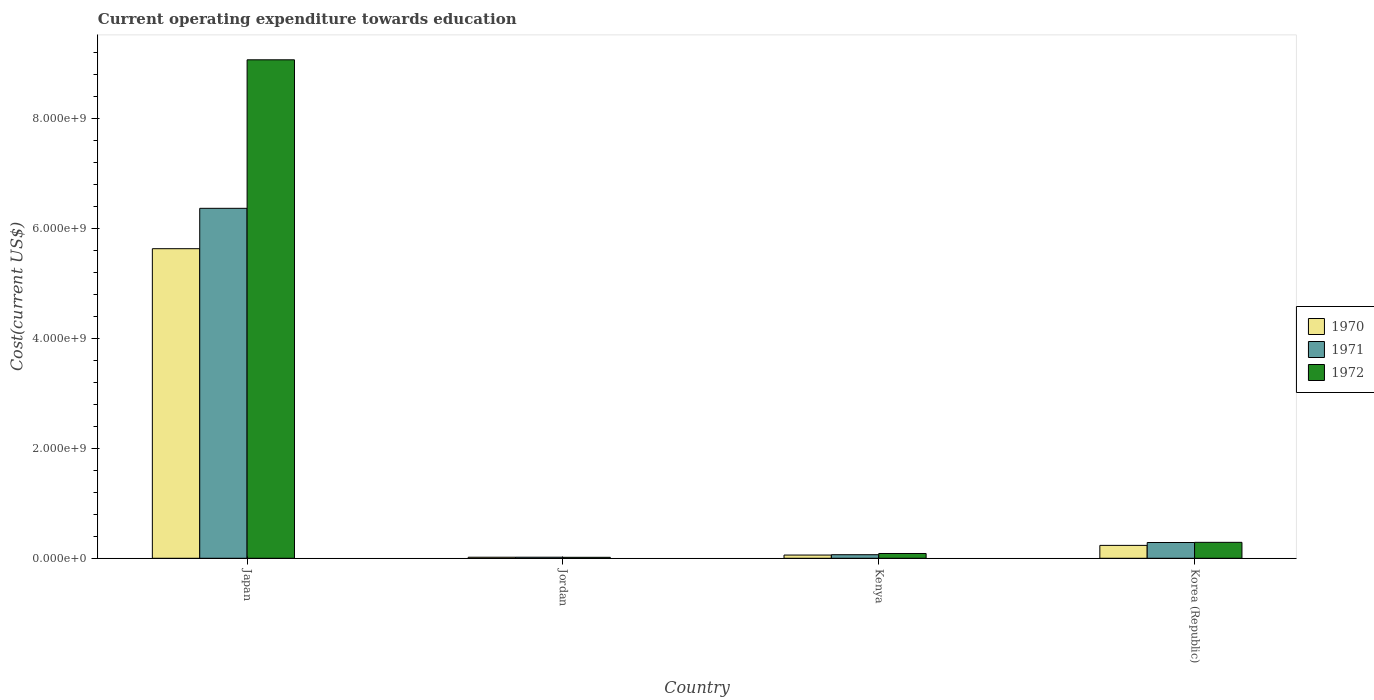How many groups of bars are there?
Your answer should be very brief. 4. Are the number of bars per tick equal to the number of legend labels?
Offer a terse response. Yes. Are the number of bars on each tick of the X-axis equal?
Your response must be concise. Yes. What is the label of the 3rd group of bars from the left?
Provide a succinct answer. Kenya. In how many cases, is the number of bars for a given country not equal to the number of legend labels?
Offer a very short reply. 0. What is the expenditure towards education in 1970 in Kenya?
Offer a terse response. 5.85e+07. Across all countries, what is the maximum expenditure towards education in 1971?
Your answer should be very brief. 6.37e+09. Across all countries, what is the minimum expenditure towards education in 1972?
Provide a succinct answer. 1.76e+07. In which country was the expenditure towards education in 1972 maximum?
Keep it short and to the point. Japan. In which country was the expenditure towards education in 1971 minimum?
Ensure brevity in your answer.  Jordan. What is the total expenditure towards education in 1972 in the graph?
Make the answer very short. 9.47e+09. What is the difference between the expenditure towards education in 1971 in Kenya and that in Korea (Republic)?
Provide a short and direct response. -2.22e+08. What is the difference between the expenditure towards education in 1972 in Kenya and the expenditure towards education in 1970 in Korea (Republic)?
Offer a terse response. -1.47e+08. What is the average expenditure towards education in 1972 per country?
Provide a short and direct response. 2.37e+09. What is the difference between the expenditure towards education of/in 1972 and expenditure towards education of/in 1970 in Jordan?
Provide a short and direct response. -1.49e+06. What is the ratio of the expenditure towards education in 1971 in Jordan to that in Kenya?
Give a very brief answer. 0.3. Is the expenditure towards education in 1971 in Kenya less than that in Korea (Republic)?
Provide a short and direct response. Yes. What is the difference between the highest and the second highest expenditure towards education in 1970?
Your answer should be very brief. 5.40e+09. What is the difference between the highest and the lowest expenditure towards education in 1972?
Make the answer very short. 9.05e+09. In how many countries, is the expenditure towards education in 1971 greater than the average expenditure towards education in 1971 taken over all countries?
Provide a short and direct response. 1. Is the sum of the expenditure towards education in 1971 in Jordan and Kenya greater than the maximum expenditure towards education in 1972 across all countries?
Ensure brevity in your answer.  No. What does the 1st bar from the left in Kenya represents?
Ensure brevity in your answer.  1970. Is it the case that in every country, the sum of the expenditure towards education in 1971 and expenditure towards education in 1970 is greater than the expenditure towards education in 1972?
Give a very brief answer. Yes. How many bars are there?
Offer a very short reply. 12. What is the difference between two consecutive major ticks on the Y-axis?
Provide a succinct answer. 2.00e+09. Does the graph contain any zero values?
Keep it short and to the point. No. How many legend labels are there?
Your answer should be compact. 3. What is the title of the graph?
Your answer should be very brief. Current operating expenditure towards education. Does "2006" appear as one of the legend labels in the graph?
Your response must be concise. No. What is the label or title of the Y-axis?
Offer a very short reply. Cost(current US$). What is the Cost(current US$) in 1970 in Japan?
Ensure brevity in your answer.  5.63e+09. What is the Cost(current US$) in 1971 in Japan?
Offer a terse response. 6.37e+09. What is the Cost(current US$) in 1972 in Japan?
Make the answer very short. 9.07e+09. What is the Cost(current US$) in 1970 in Jordan?
Ensure brevity in your answer.  1.91e+07. What is the Cost(current US$) of 1971 in Jordan?
Give a very brief answer. 1.94e+07. What is the Cost(current US$) of 1972 in Jordan?
Your answer should be compact. 1.76e+07. What is the Cost(current US$) of 1970 in Kenya?
Provide a succinct answer. 5.85e+07. What is the Cost(current US$) of 1971 in Kenya?
Your response must be concise. 6.49e+07. What is the Cost(current US$) in 1972 in Kenya?
Keep it short and to the point. 8.71e+07. What is the Cost(current US$) of 1970 in Korea (Republic)?
Provide a short and direct response. 2.34e+08. What is the Cost(current US$) in 1971 in Korea (Republic)?
Your answer should be very brief. 2.87e+08. What is the Cost(current US$) in 1972 in Korea (Republic)?
Offer a terse response. 2.90e+08. Across all countries, what is the maximum Cost(current US$) of 1970?
Provide a short and direct response. 5.63e+09. Across all countries, what is the maximum Cost(current US$) of 1971?
Provide a short and direct response. 6.37e+09. Across all countries, what is the maximum Cost(current US$) of 1972?
Your response must be concise. 9.07e+09. Across all countries, what is the minimum Cost(current US$) in 1970?
Make the answer very short. 1.91e+07. Across all countries, what is the minimum Cost(current US$) of 1971?
Your response must be concise. 1.94e+07. Across all countries, what is the minimum Cost(current US$) in 1972?
Your answer should be compact. 1.76e+07. What is the total Cost(current US$) in 1970 in the graph?
Offer a terse response. 5.95e+09. What is the total Cost(current US$) in 1971 in the graph?
Your answer should be compact. 6.74e+09. What is the total Cost(current US$) of 1972 in the graph?
Offer a terse response. 9.47e+09. What is the difference between the Cost(current US$) of 1970 in Japan and that in Jordan?
Give a very brief answer. 5.62e+09. What is the difference between the Cost(current US$) in 1971 in Japan and that in Jordan?
Ensure brevity in your answer.  6.35e+09. What is the difference between the Cost(current US$) in 1972 in Japan and that in Jordan?
Give a very brief answer. 9.05e+09. What is the difference between the Cost(current US$) in 1970 in Japan and that in Kenya?
Give a very brief answer. 5.58e+09. What is the difference between the Cost(current US$) in 1971 in Japan and that in Kenya?
Keep it short and to the point. 6.30e+09. What is the difference between the Cost(current US$) in 1972 in Japan and that in Kenya?
Offer a very short reply. 8.99e+09. What is the difference between the Cost(current US$) of 1970 in Japan and that in Korea (Republic)?
Provide a succinct answer. 5.40e+09. What is the difference between the Cost(current US$) of 1971 in Japan and that in Korea (Republic)?
Offer a very short reply. 6.08e+09. What is the difference between the Cost(current US$) in 1972 in Japan and that in Korea (Republic)?
Offer a terse response. 8.78e+09. What is the difference between the Cost(current US$) in 1970 in Jordan and that in Kenya?
Keep it short and to the point. -3.94e+07. What is the difference between the Cost(current US$) in 1971 in Jordan and that in Kenya?
Make the answer very short. -4.55e+07. What is the difference between the Cost(current US$) in 1972 in Jordan and that in Kenya?
Your answer should be very brief. -6.95e+07. What is the difference between the Cost(current US$) of 1970 in Jordan and that in Korea (Republic)?
Offer a very short reply. -2.15e+08. What is the difference between the Cost(current US$) in 1971 in Jordan and that in Korea (Republic)?
Offer a very short reply. -2.68e+08. What is the difference between the Cost(current US$) of 1972 in Jordan and that in Korea (Republic)?
Your answer should be compact. -2.72e+08. What is the difference between the Cost(current US$) of 1970 in Kenya and that in Korea (Republic)?
Make the answer very short. -1.76e+08. What is the difference between the Cost(current US$) of 1971 in Kenya and that in Korea (Republic)?
Your response must be concise. -2.22e+08. What is the difference between the Cost(current US$) of 1972 in Kenya and that in Korea (Republic)?
Offer a terse response. -2.03e+08. What is the difference between the Cost(current US$) of 1970 in Japan and the Cost(current US$) of 1971 in Jordan?
Your response must be concise. 5.61e+09. What is the difference between the Cost(current US$) in 1970 in Japan and the Cost(current US$) in 1972 in Jordan?
Your response must be concise. 5.62e+09. What is the difference between the Cost(current US$) in 1971 in Japan and the Cost(current US$) in 1972 in Jordan?
Make the answer very short. 6.35e+09. What is the difference between the Cost(current US$) in 1970 in Japan and the Cost(current US$) in 1971 in Kenya?
Make the answer very short. 5.57e+09. What is the difference between the Cost(current US$) in 1970 in Japan and the Cost(current US$) in 1972 in Kenya?
Offer a terse response. 5.55e+09. What is the difference between the Cost(current US$) in 1971 in Japan and the Cost(current US$) in 1972 in Kenya?
Offer a very short reply. 6.28e+09. What is the difference between the Cost(current US$) of 1970 in Japan and the Cost(current US$) of 1971 in Korea (Republic)?
Ensure brevity in your answer.  5.35e+09. What is the difference between the Cost(current US$) in 1970 in Japan and the Cost(current US$) in 1972 in Korea (Republic)?
Your answer should be compact. 5.34e+09. What is the difference between the Cost(current US$) of 1971 in Japan and the Cost(current US$) of 1972 in Korea (Republic)?
Offer a terse response. 6.08e+09. What is the difference between the Cost(current US$) of 1970 in Jordan and the Cost(current US$) of 1971 in Kenya?
Your answer should be compact. -4.58e+07. What is the difference between the Cost(current US$) in 1970 in Jordan and the Cost(current US$) in 1972 in Kenya?
Give a very brief answer. -6.80e+07. What is the difference between the Cost(current US$) of 1971 in Jordan and the Cost(current US$) of 1972 in Kenya?
Your response must be concise. -6.77e+07. What is the difference between the Cost(current US$) of 1970 in Jordan and the Cost(current US$) of 1971 in Korea (Republic)?
Your response must be concise. -2.68e+08. What is the difference between the Cost(current US$) of 1970 in Jordan and the Cost(current US$) of 1972 in Korea (Republic)?
Your answer should be compact. -2.71e+08. What is the difference between the Cost(current US$) in 1971 in Jordan and the Cost(current US$) in 1972 in Korea (Republic)?
Your answer should be compact. -2.71e+08. What is the difference between the Cost(current US$) in 1970 in Kenya and the Cost(current US$) in 1971 in Korea (Republic)?
Offer a very short reply. -2.28e+08. What is the difference between the Cost(current US$) of 1970 in Kenya and the Cost(current US$) of 1972 in Korea (Republic)?
Ensure brevity in your answer.  -2.31e+08. What is the difference between the Cost(current US$) in 1971 in Kenya and the Cost(current US$) in 1972 in Korea (Republic)?
Provide a short and direct response. -2.25e+08. What is the average Cost(current US$) in 1970 per country?
Provide a succinct answer. 1.49e+09. What is the average Cost(current US$) in 1971 per country?
Keep it short and to the point. 1.69e+09. What is the average Cost(current US$) of 1972 per country?
Give a very brief answer. 2.37e+09. What is the difference between the Cost(current US$) of 1970 and Cost(current US$) of 1971 in Japan?
Provide a short and direct response. -7.35e+08. What is the difference between the Cost(current US$) in 1970 and Cost(current US$) in 1972 in Japan?
Make the answer very short. -3.44e+09. What is the difference between the Cost(current US$) of 1971 and Cost(current US$) of 1972 in Japan?
Your answer should be compact. -2.70e+09. What is the difference between the Cost(current US$) of 1970 and Cost(current US$) of 1971 in Jordan?
Give a very brief answer. -3.14e+05. What is the difference between the Cost(current US$) of 1970 and Cost(current US$) of 1972 in Jordan?
Ensure brevity in your answer.  1.49e+06. What is the difference between the Cost(current US$) in 1971 and Cost(current US$) in 1972 in Jordan?
Keep it short and to the point. 1.80e+06. What is the difference between the Cost(current US$) of 1970 and Cost(current US$) of 1971 in Kenya?
Ensure brevity in your answer.  -6.41e+06. What is the difference between the Cost(current US$) in 1970 and Cost(current US$) in 1972 in Kenya?
Your answer should be compact. -2.86e+07. What is the difference between the Cost(current US$) in 1971 and Cost(current US$) in 1972 in Kenya?
Your answer should be compact. -2.22e+07. What is the difference between the Cost(current US$) of 1970 and Cost(current US$) of 1971 in Korea (Republic)?
Provide a short and direct response. -5.25e+07. What is the difference between the Cost(current US$) of 1970 and Cost(current US$) of 1972 in Korea (Republic)?
Make the answer very short. -5.55e+07. What is the difference between the Cost(current US$) in 1971 and Cost(current US$) in 1972 in Korea (Republic)?
Offer a very short reply. -2.95e+06. What is the ratio of the Cost(current US$) in 1970 in Japan to that in Jordan?
Keep it short and to the point. 295.14. What is the ratio of the Cost(current US$) in 1971 in Japan to that in Jordan?
Your answer should be compact. 328.24. What is the ratio of the Cost(current US$) of 1972 in Japan to that in Jordan?
Offer a terse response. 515.5. What is the ratio of the Cost(current US$) of 1970 in Japan to that in Kenya?
Keep it short and to the point. 96.35. What is the ratio of the Cost(current US$) in 1971 in Japan to that in Kenya?
Ensure brevity in your answer.  98.15. What is the ratio of the Cost(current US$) in 1972 in Japan to that in Kenya?
Offer a very short reply. 104.19. What is the ratio of the Cost(current US$) in 1970 in Japan to that in Korea (Republic)?
Your answer should be very brief. 24.03. What is the ratio of the Cost(current US$) in 1971 in Japan to that in Korea (Republic)?
Your answer should be compact. 22.2. What is the ratio of the Cost(current US$) in 1972 in Japan to that in Korea (Republic)?
Offer a very short reply. 31.29. What is the ratio of the Cost(current US$) in 1970 in Jordan to that in Kenya?
Provide a short and direct response. 0.33. What is the ratio of the Cost(current US$) in 1971 in Jordan to that in Kenya?
Provide a succinct answer. 0.3. What is the ratio of the Cost(current US$) in 1972 in Jordan to that in Kenya?
Your answer should be very brief. 0.2. What is the ratio of the Cost(current US$) of 1970 in Jordan to that in Korea (Republic)?
Keep it short and to the point. 0.08. What is the ratio of the Cost(current US$) of 1971 in Jordan to that in Korea (Republic)?
Make the answer very short. 0.07. What is the ratio of the Cost(current US$) of 1972 in Jordan to that in Korea (Republic)?
Your answer should be very brief. 0.06. What is the ratio of the Cost(current US$) of 1970 in Kenya to that in Korea (Republic)?
Make the answer very short. 0.25. What is the ratio of the Cost(current US$) in 1971 in Kenya to that in Korea (Republic)?
Keep it short and to the point. 0.23. What is the ratio of the Cost(current US$) of 1972 in Kenya to that in Korea (Republic)?
Give a very brief answer. 0.3. What is the difference between the highest and the second highest Cost(current US$) in 1970?
Provide a succinct answer. 5.40e+09. What is the difference between the highest and the second highest Cost(current US$) of 1971?
Make the answer very short. 6.08e+09. What is the difference between the highest and the second highest Cost(current US$) in 1972?
Offer a very short reply. 8.78e+09. What is the difference between the highest and the lowest Cost(current US$) in 1970?
Ensure brevity in your answer.  5.62e+09. What is the difference between the highest and the lowest Cost(current US$) in 1971?
Offer a terse response. 6.35e+09. What is the difference between the highest and the lowest Cost(current US$) in 1972?
Offer a terse response. 9.05e+09. 